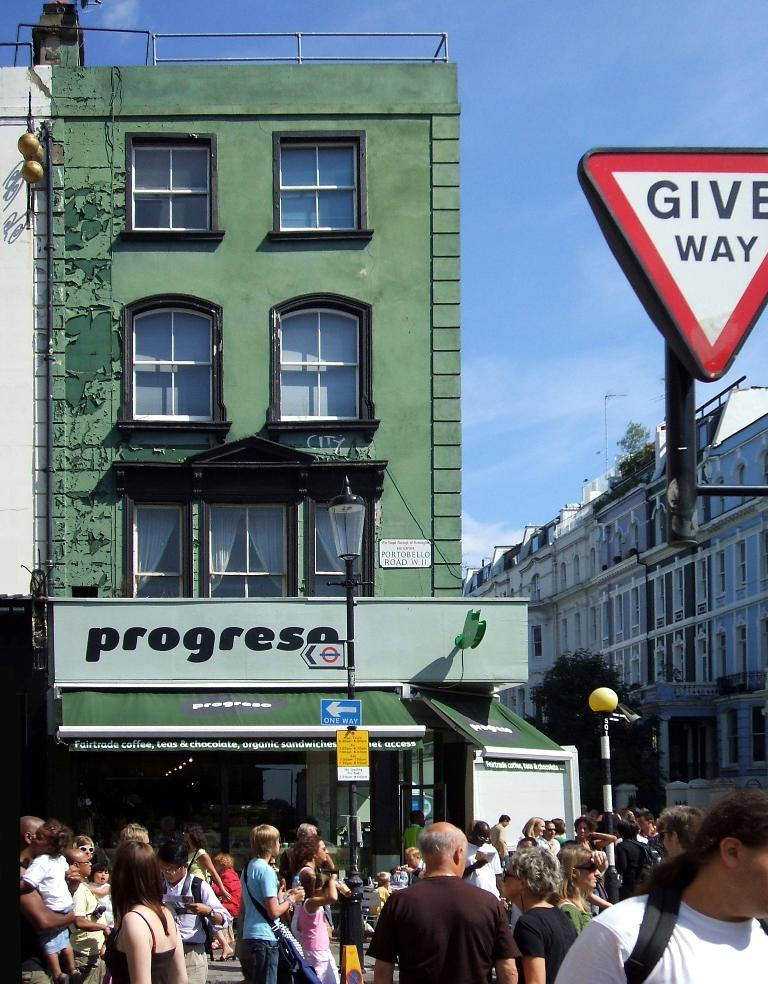How many people can be seen at the bottom of the image? There are many people at the bottom of the image. What structures are located in the middle of the image? There are buildings in the middle of the image. What type of signage is present in the image? Sign boards are present in the image. Can you read any text in the image? Yes, text is visible in the image. What type of lighting is present in the image? Street lights are in the image. What type of vertical structures are present in the image? Poles are present in the image. What type of openings are visible in the buildings? Windows are visible in the image. What type of accessory is present in the image? Glasses are present in the image. What type of barrier is present in the image? There is a wall in the image. What part of the natural environment is visible in the image? The sky is visible in the image, and clouds are present. Can you hear the harmony created by the guitar in the image? There is no guitar present in the image, so it is not possible to hear any harmony. 